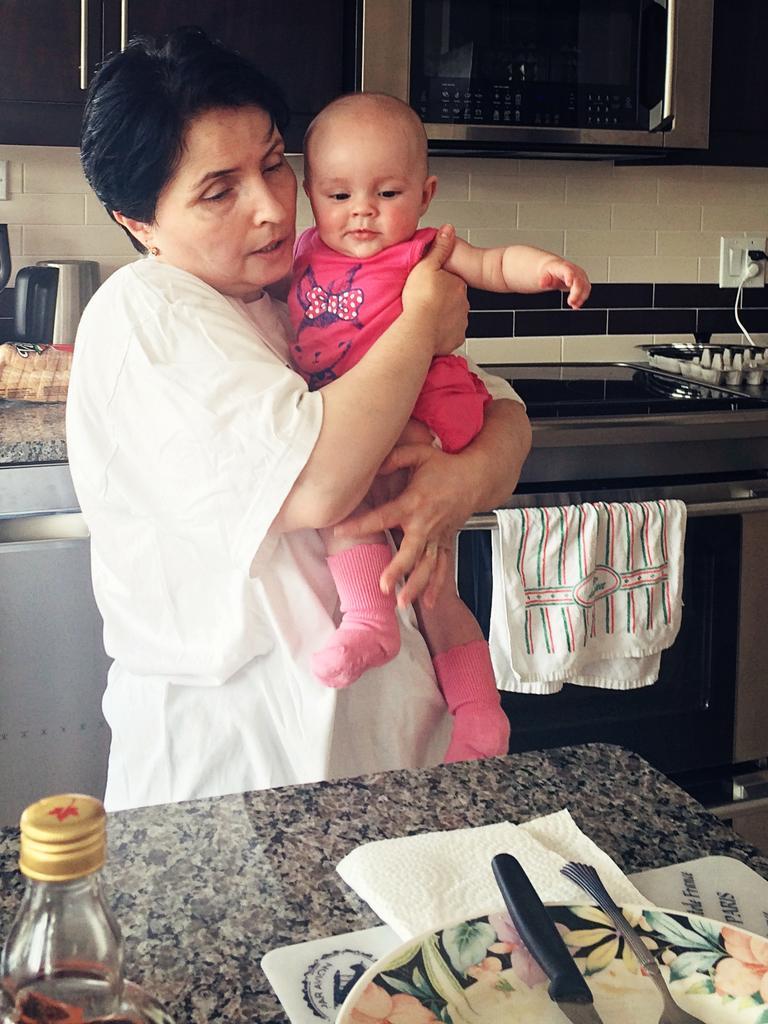Please provide a concise description of this image. In the above picture i could see a woman carrying a baby girl in her hands. The woman is wearing white dress and baby is wearing a pink colored dress, the baby is having a socks to her legs. I could see a counter top in the bottom of the picture, on the counter top there is a tissue paper, on the tissue paper there is a plate and on the plate there is a knife and spoon. Beside the plate there is a bottle made up of glass and is covered with a lid. In the back ground of the picture i can see the cabinets of the kitchen room and there is a micro-oven attached to those cabinets and there is a tiles to the wall in the kitchen room. In the right corner of the picture i could see the electric stove and electric oven which is attached to the counter top of the kitchen room. There is some cables moving to the switchboard of the kitchen room. There are some utensils to the left side corner of the picture. 